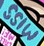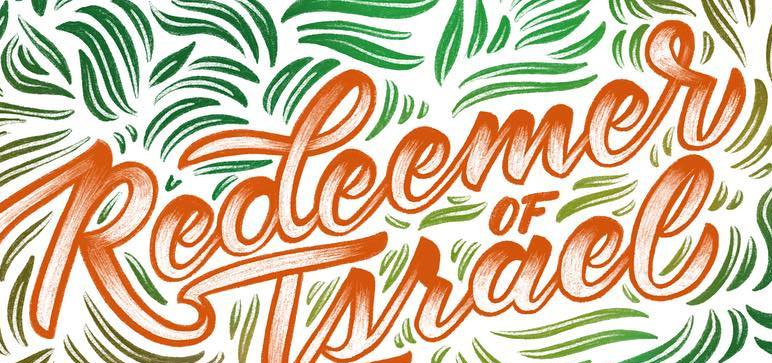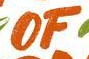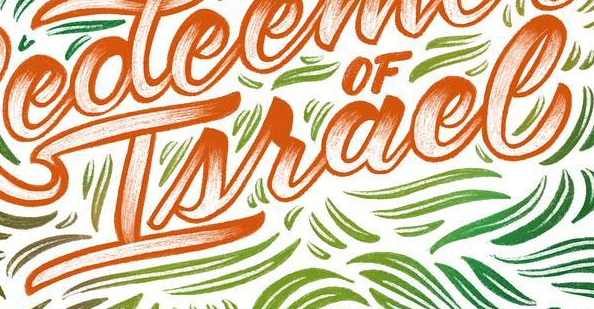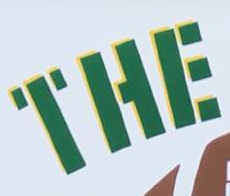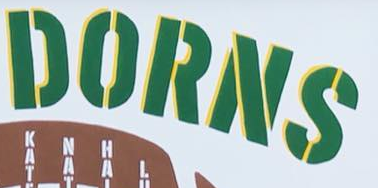What text is displayed in these images sequentially, separated by a semicolon? MISS; Redeemer; OF; Israel; THE; DORNS 